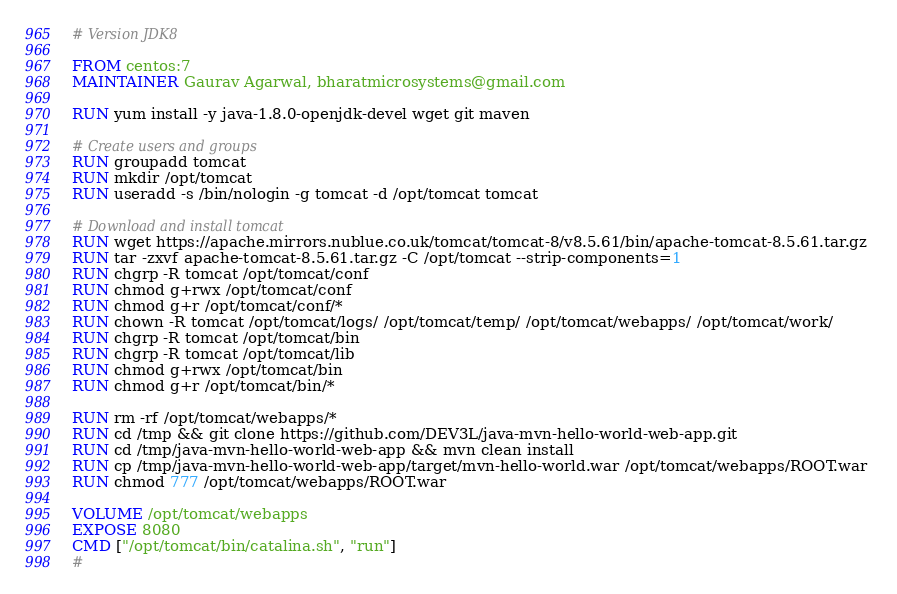<code> <loc_0><loc_0><loc_500><loc_500><_Dockerfile_># Version JDK8

FROM centos:7
MAINTAINER Gaurav Agarwal, bharatmicrosystems@gmail.com

RUN yum install -y java-1.8.0-openjdk-devel wget git maven

# Create users and groups
RUN groupadd tomcat
RUN mkdir /opt/tomcat
RUN useradd -s /bin/nologin -g tomcat -d /opt/tomcat tomcat

# Download and install tomcat
RUN wget https://apache.mirrors.nublue.co.uk/tomcat/tomcat-8/v8.5.61/bin/apache-tomcat-8.5.61.tar.gz 
RUN tar -zxvf apache-tomcat-8.5.61.tar.gz -C /opt/tomcat --strip-components=1
RUN chgrp -R tomcat /opt/tomcat/conf
RUN chmod g+rwx /opt/tomcat/conf
RUN chmod g+r /opt/tomcat/conf/*
RUN chown -R tomcat /opt/tomcat/logs/ /opt/tomcat/temp/ /opt/tomcat/webapps/ /opt/tomcat/work/
RUN chgrp -R tomcat /opt/tomcat/bin
RUN chgrp -R tomcat /opt/tomcat/lib
RUN chmod g+rwx /opt/tomcat/bin
RUN chmod g+r /opt/tomcat/bin/*

RUN rm -rf /opt/tomcat/webapps/*
RUN cd /tmp && git clone https://github.com/DEV3L/java-mvn-hello-world-web-app.git
RUN cd /tmp/java-mvn-hello-world-web-app && mvn clean install
RUN cp /tmp/java-mvn-hello-world-web-app/target/mvn-hello-world.war /opt/tomcat/webapps/ROOT.war
RUN chmod 777 /opt/tomcat/webapps/ROOT.war

VOLUME /opt/tomcat/webapps
EXPOSE 8080
CMD ["/opt/tomcat/bin/catalina.sh", "run"]
#
</code> 